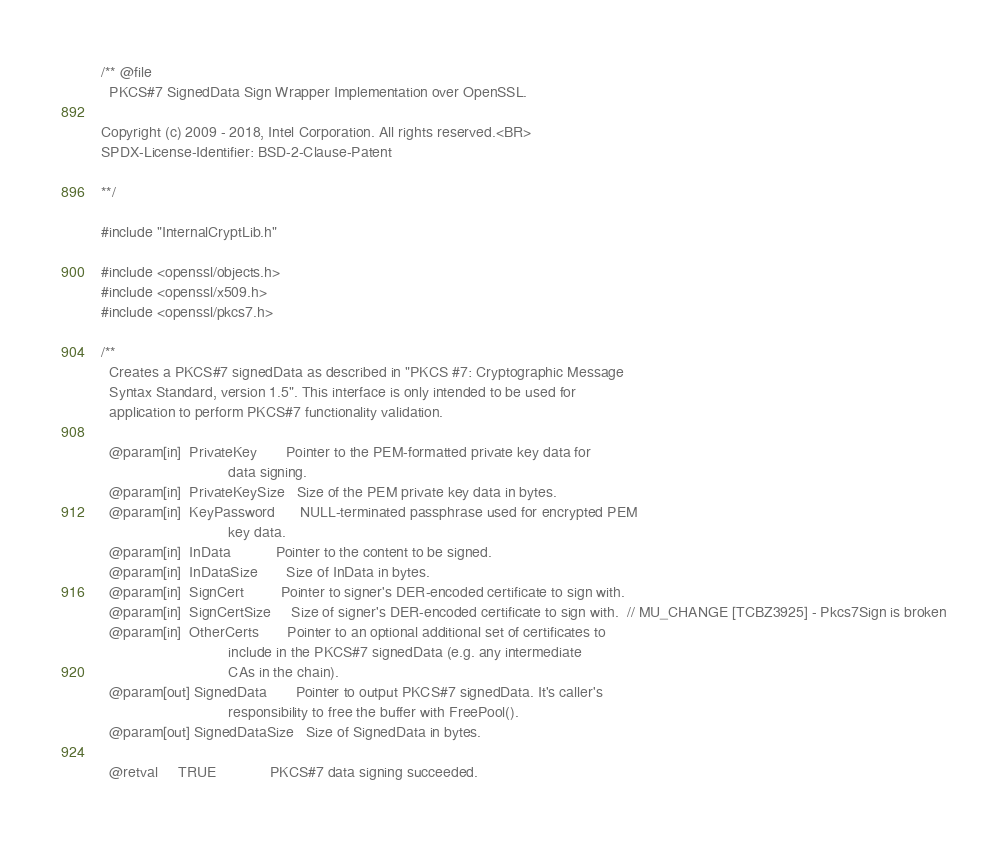Convert code to text. <code><loc_0><loc_0><loc_500><loc_500><_C_>/** @file
  PKCS#7 SignedData Sign Wrapper Implementation over OpenSSL.

Copyright (c) 2009 - 2018, Intel Corporation. All rights reserved.<BR>
SPDX-License-Identifier: BSD-2-Clause-Patent

**/

#include "InternalCryptLib.h"

#include <openssl/objects.h>
#include <openssl/x509.h>
#include <openssl/pkcs7.h>

/**
  Creates a PKCS#7 signedData as described in "PKCS #7: Cryptographic Message
  Syntax Standard, version 1.5". This interface is only intended to be used for
  application to perform PKCS#7 functionality validation.

  @param[in]  PrivateKey       Pointer to the PEM-formatted private key data for
                               data signing.
  @param[in]  PrivateKeySize   Size of the PEM private key data in bytes.
  @param[in]  KeyPassword      NULL-terminated passphrase used for encrypted PEM
                               key data.
  @param[in]  InData           Pointer to the content to be signed.
  @param[in]  InDataSize       Size of InData in bytes.
  @param[in]  SignCert         Pointer to signer's DER-encoded certificate to sign with.
  @param[in]  SignCertSize     Size of signer's DER-encoded certificate to sign with.  // MU_CHANGE [TCBZ3925] - Pkcs7Sign is broken
  @param[in]  OtherCerts       Pointer to an optional additional set of certificates to
                               include in the PKCS#7 signedData (e.g. any intermediate
                               CAs in the chain).
  @param[out] SignedData       Pointer to output PKCS#7 signedData. It's caller's
                               responsibility to free the buffer with FreePool().
  @param[out] SignedDataSize   Size of SignedData in bytes.

  @retval     TRUE             PKCS#7 data signing succeeded.</code> 